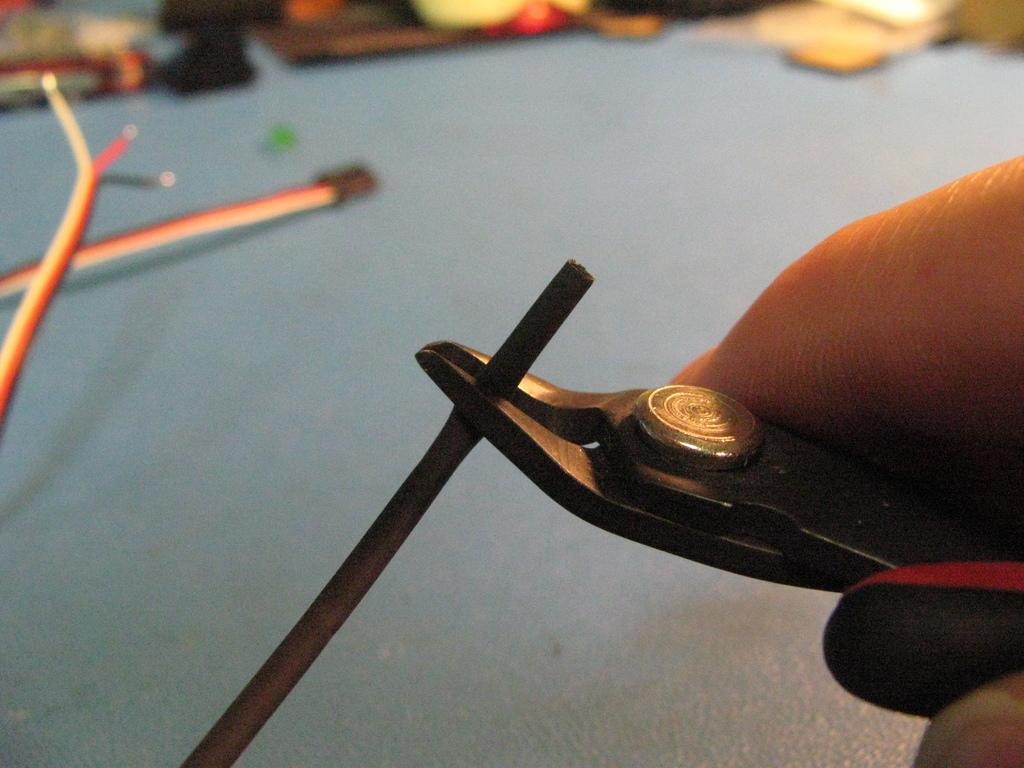What is the person holding in the image? The person is holding a black object in the image. What color is the surface visible in the background of the image? The surface visible in the background of the image is blue. What scent can be detected from the cow in the image? There is no cow present in the image, so no scent can be detected. 